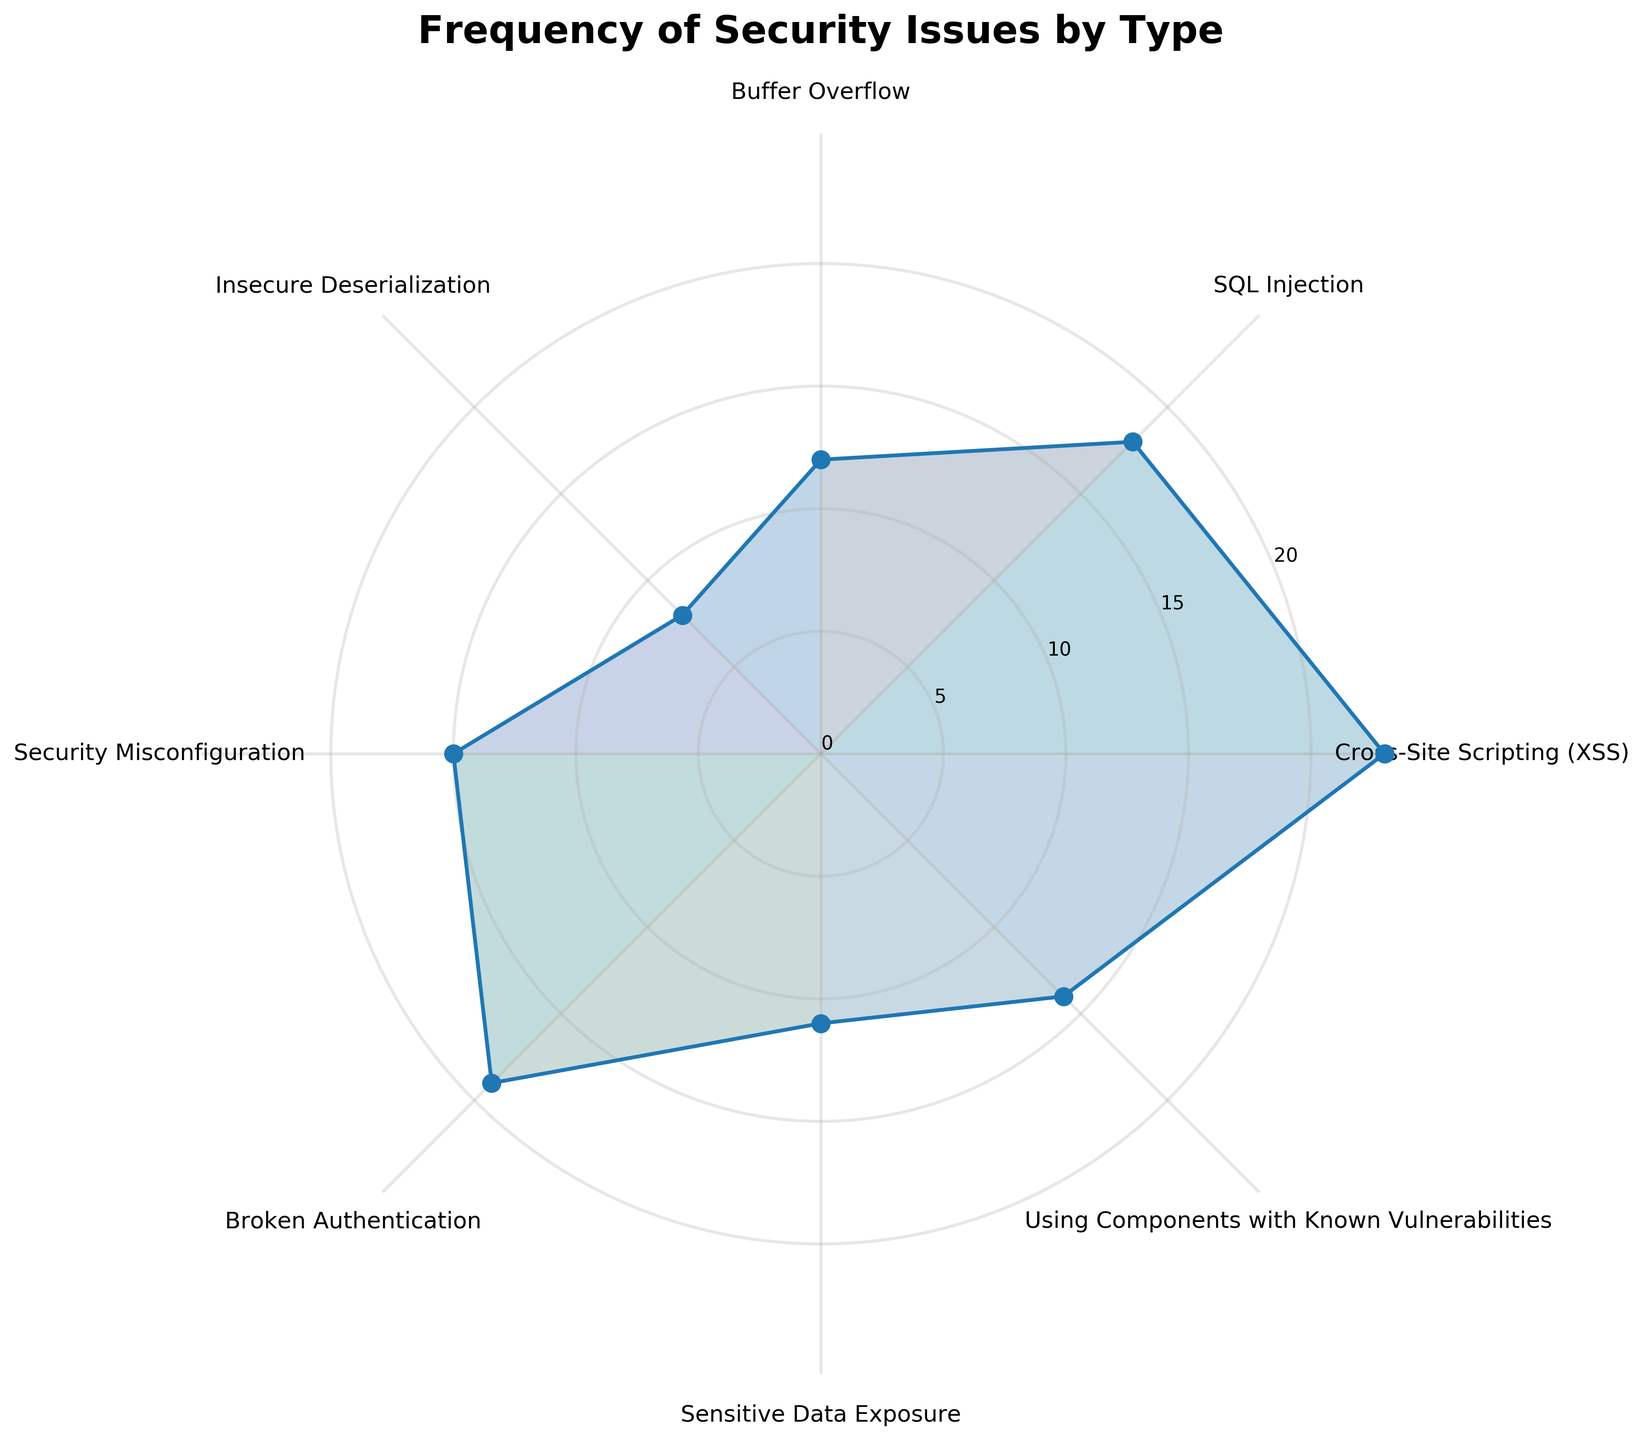What's the title of the figure? The title is displayed at the top of the figure, which reads "Frequency of Security Issues by Type"
Answer: Frequency of Security Issues by Type How many security issue types are represented in the chart? The chart has labeled sections for each security issue, and there are 8 different types listed.
Answer: 8 Which type of security issue has the highest frequency? By looking at the lengths of the plotted lines, the security issue type that extends the furthest is "Cross-Site Scripting (XSS)"
Answer: Cross-Site Scripting (XSS) What is the frequency of SQL Injection issues? The radial length for "SQL Injection" can be read directly from the chart, showing a frequency of 18.
Answer: 18 Compare the frequencies of "Buffer Overflow" and "Sensitive Data Exposure". Which one is higher? By comparing the two lines in the plot, "Buffer Overflow" (12) is less than "Sensitive Data Exposure" (11).
Answer: Buffer Overflow What's the average frequency of all security issues displayed? Adding up all frequencies (23+18+12+8+15+19+11+14 = 120) and dividing by the number of issues (8) gives the average: 120/8.
Answer: 15 Which type of security issue has a frequency close to the average frequency of all issues? The average frequency is 15. "Security Misconfiguration" has a frequency of 15, which is exactly the average.
Answer: Security Misconfiguration What is the combined frequency of Cross-Site Scripting (XSS) and SQL Injection issues? Summing the frequencies of Cross-Site Scripting (23) and SQL Injection (18) gives: 23 + 18 = 41.
Answer: 41 